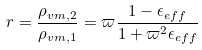Convert formula to latex. <formula><loc_0><loc_0><loc_500><loc_500>r = \frac { \rho _ { v m , 2 } } { \rho _ { v m , 1 } } = \varpi \frac { 1 - \epsilon _ { e f f } } { 1 + \varpi ^ { 2 } \epsilon _ { e f f } }</formula> 